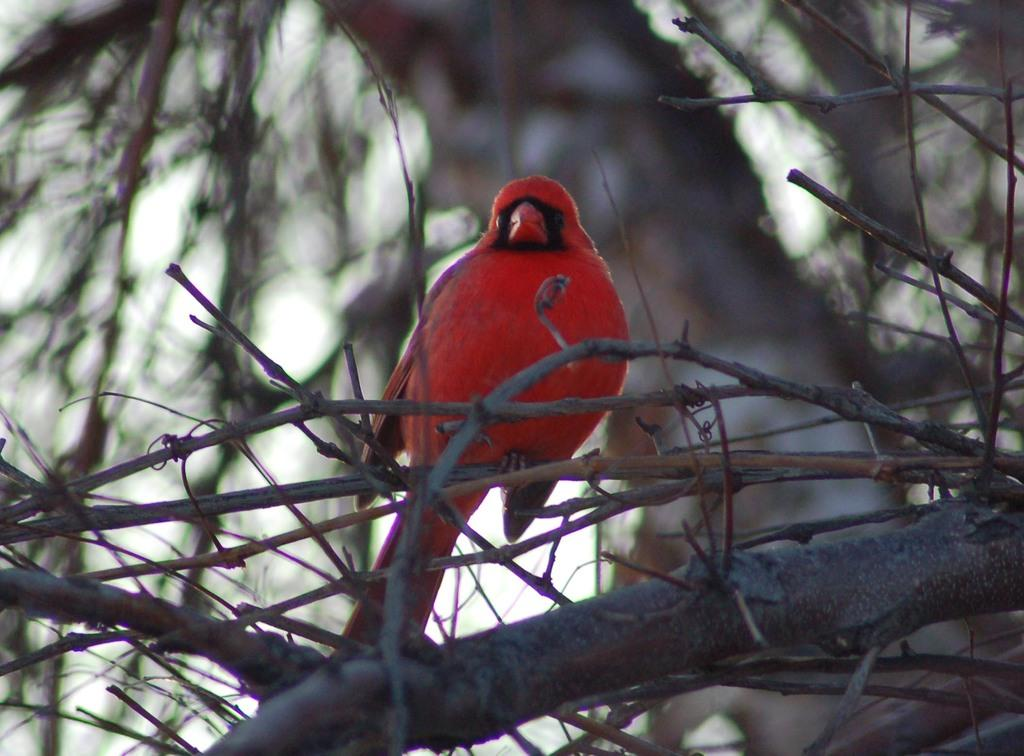What type of bird can be seen in the image? There is a red bird in the image. Where is the red bird located? The red bird is on a stem. What can be observed about the background of the image? The background of the image is blurry. What part of the natural environment is visible in the image? The sky is visible in the image. What type of hammer can be seen in the image? There is no hammer present in the image. How does the red bird use its sense of smell in the image? Birds do not have a sense of smell, so this question is not applicable to the image. 